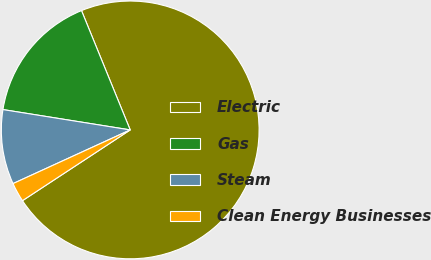Convert chart. <chart><loc_0><loc_0><loc_500><loc_500><pie_chart><fcel>Electric<fcel>Gas<fcel>Steam<fcel>Clean Energy Businesses<nl><fcel>71.93%<fcel>16.31%<fcel>9.36%<fcel>2.41%<nl></chart> 